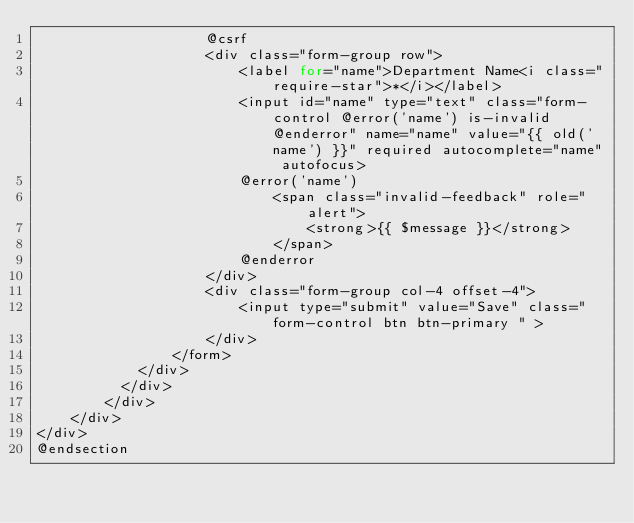<code> <loc_0><loc_0><loc_500><loc_500><_PHP_>                    @csrf
                    <div class="form-group row">
                        <label for="name">Department Name<i class="require-star">*</i></label>   
                        <input id="name" type="text" class="form-control @error('name') is-invalid @enderror" name="name" value="{{ old('name') }}" required autocomplete="name" autofocus>
                        @error('name')
                            <span class="invalid-feedback" role="alert">
                                <strong>{{ $message }}</strong>
                            </span>
                        @enderror
                    </div> 
                    <div class="form-group col-4 offset-4">
                        <input type="submit" value="Save" class="form-control btn btn-primary " >
                    </div>
                </form>   
            </div>
          </div> 
        </div>
    </div>    
</div>
@endsection</code> 